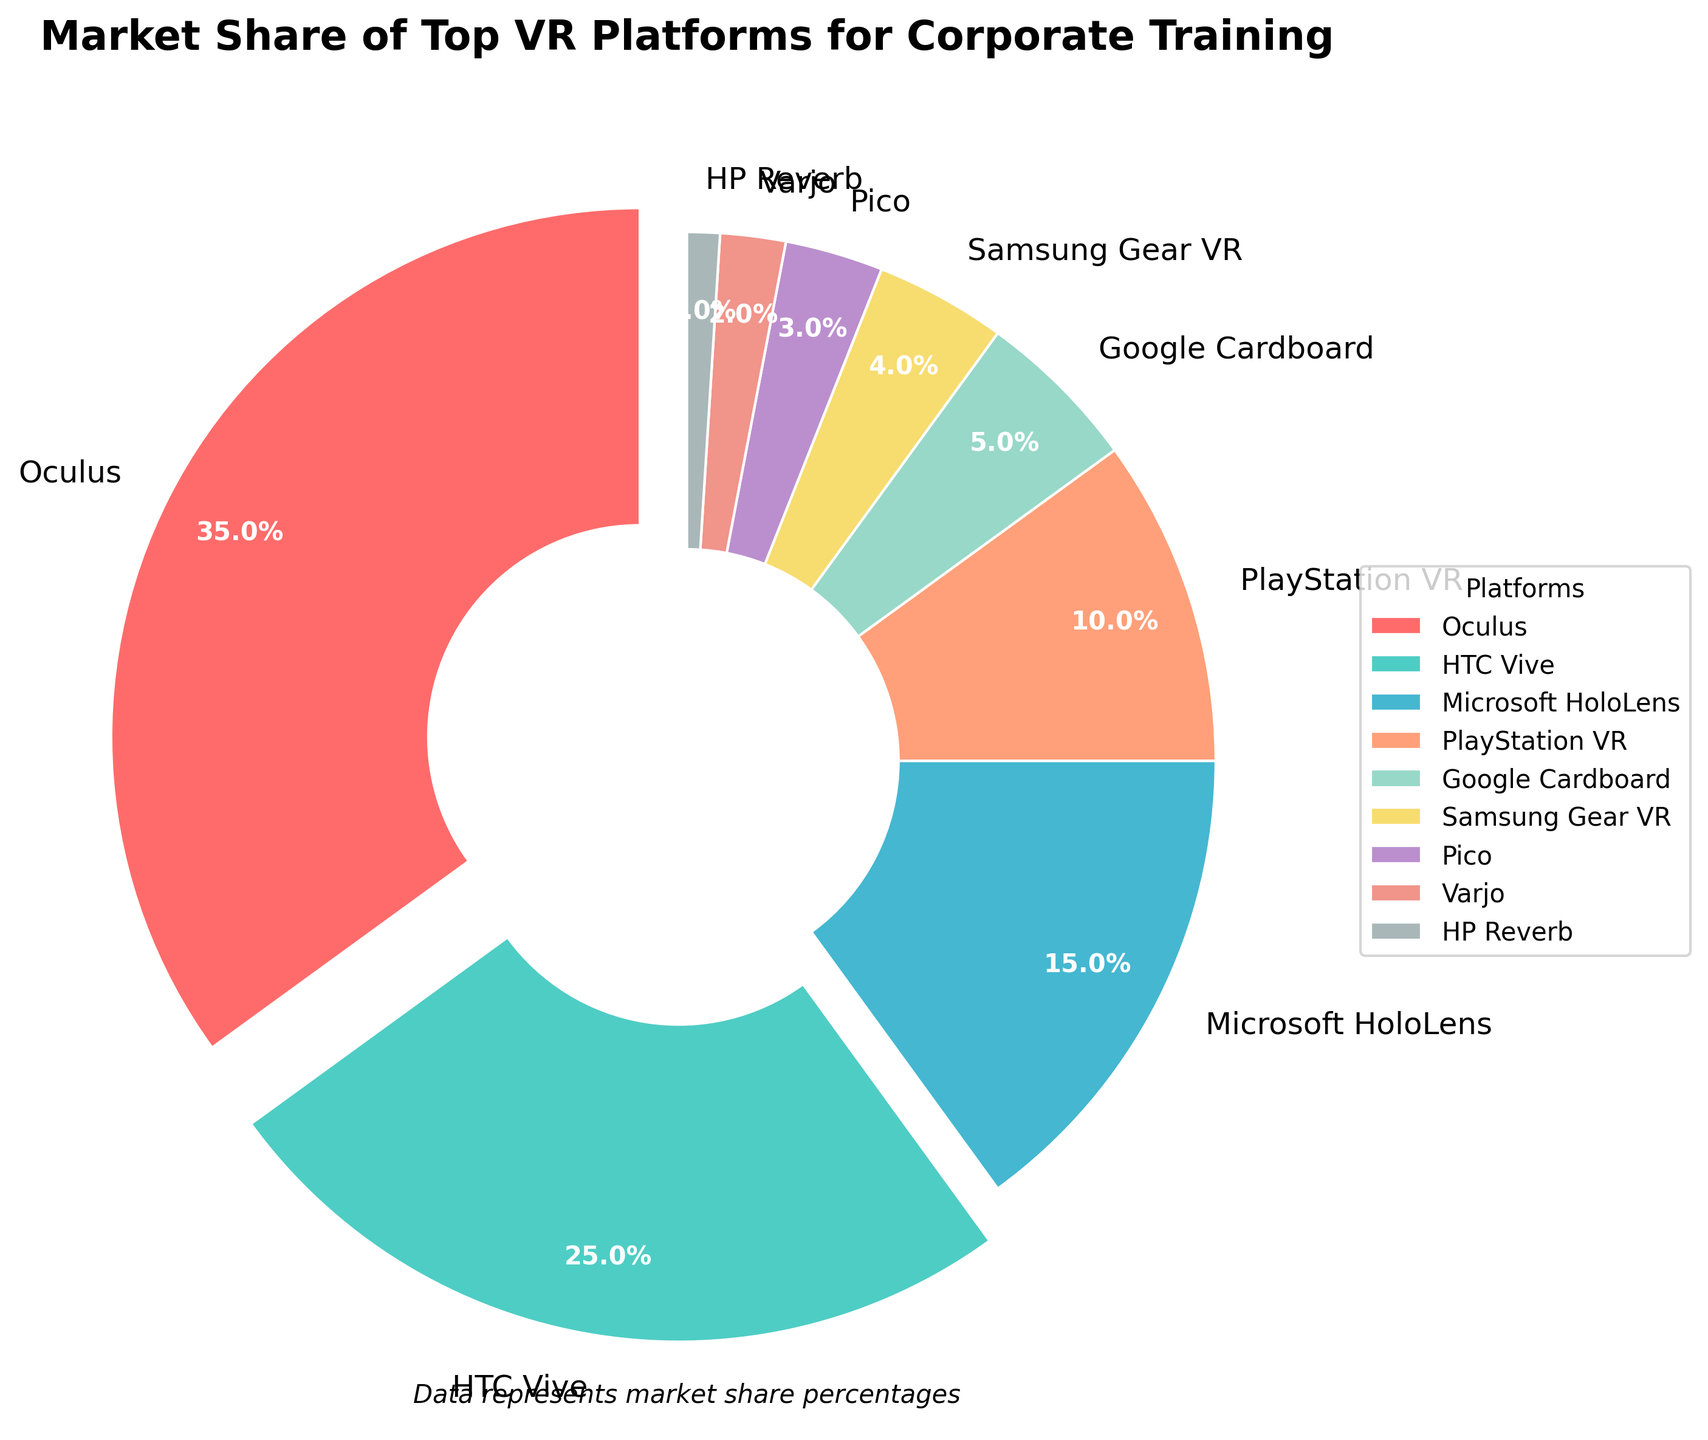What platform has the highest market share? The largest segment of the pie chart represents Oculus with 35% of the market share.
Answer: Oculus Which VR platforms combined have a market share greater than 50%? The platforms Oculus (35%) and HTC Vive (25%) together have a combined market share of 60%, which is greater than 50%.
Answer: Oculus and HTC Vive What is the combined market share of the platforms with less than 5% each? Summing up the market shares of Google Cardboard (5%), Samsung Gear VR (4%), Pico (3%), Varjo (2%), and HP Reverb (1%) gives a total market share of 15%.
Answer: 15% How does the market share of HTC Vive compare to Microsoft HoloLens? HTC Vive has a market share of 25%, while Microsoft HoloLens has a market share of 15%. Therefore, HTC Vive has a higher market share.
Answer: HTC Vive has a higher market share Which platform's segment is represented with the color green? The pie chart uses color coding, and the green segment corresponds to HTC Vive.
Answer: HTC Vive What is the difference in market share between PlayStation VR and Google Cardboard? PlayStation VR has a market share of 10%, and Google Cardboard has a market share of 5%. The difference is 10% - 5% = 5%.
Answer: 5% How do the market shares of Oculus and HTC Vive together compare to the rest of the platforms combined? Oculus (35%) and HTC Vive (25%) together have a market share of 60%. The rest of the platforms collectively have a market share of 40% (100% - 60%). Therefore, Oculus and HTC Vive together have a greater market share.
Answer: Oculus and HTC Vive have a greater market share What's the combined market share of the platforms represented by shades of blue? The pie chart uses shades of blue for Microsoft HoloLens (15%) and Pico (3%). The combined market share is 15% + 3% = 18%.
Answer: 18% Which platforms have their segments slightly exploded outwards, and why? The segments for Oculus (35%, higher than 20%) and HTC Vive (25%, higher than 20%) are slightly exploded outwards to emphasize their prominent market shares.
Answer: Oculus and HTC Vive 